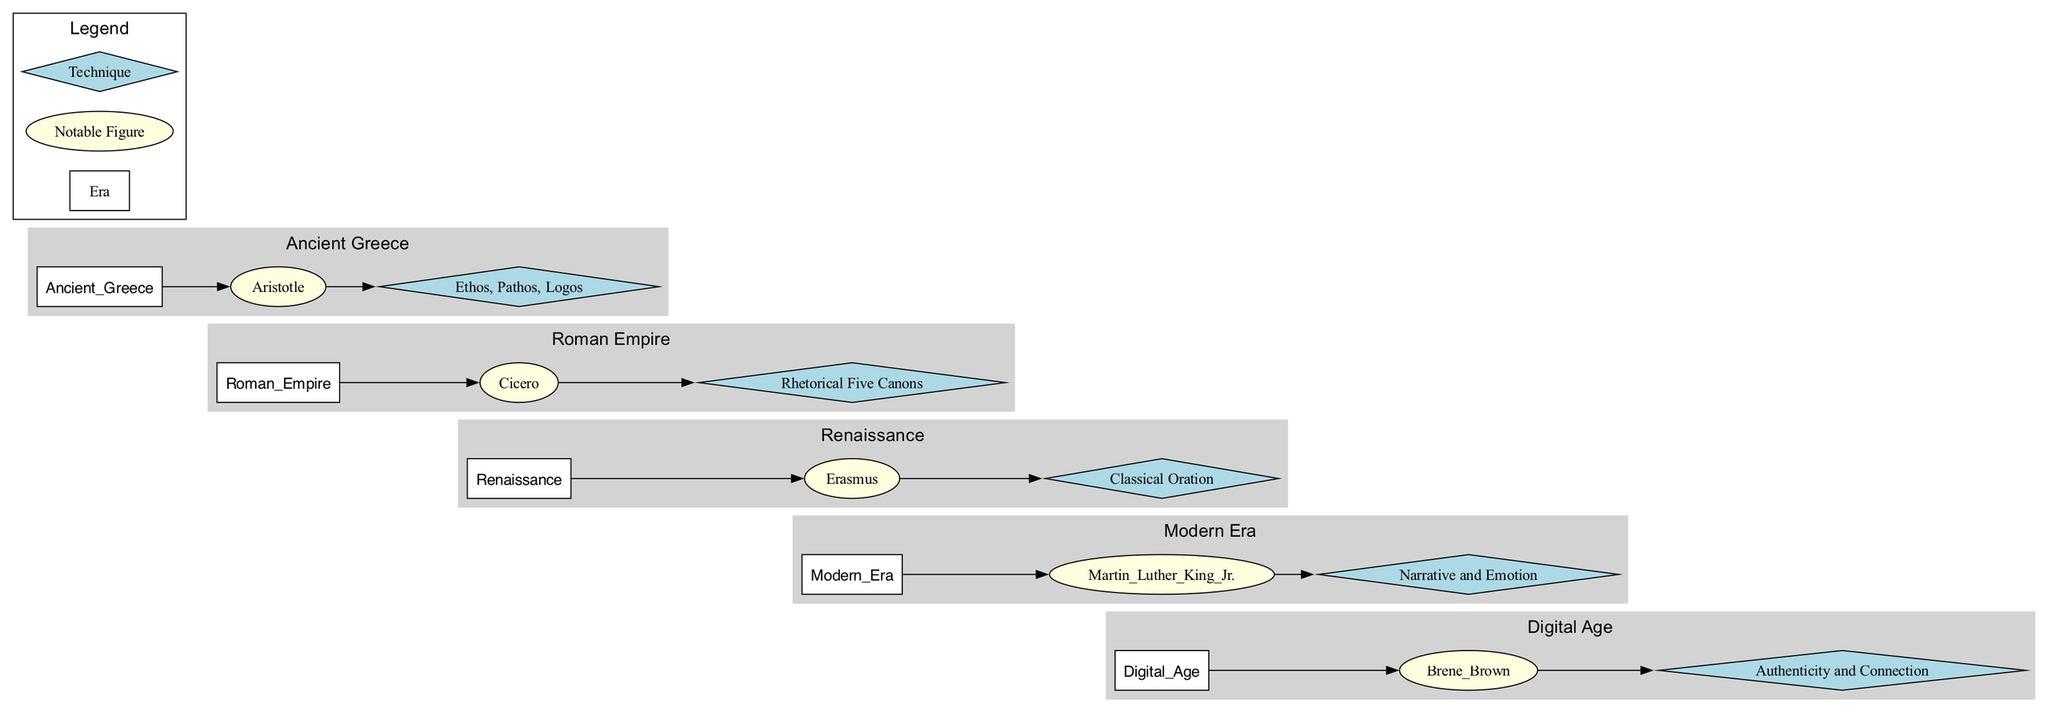What technique is associated with Martin Luther King Jr.? In the diagram, if you look for the node corresponding to Martin Luther King Jr., you'll see it directly connects to the technique node labeled "Narrative and Emotion."
Answer: Narrative and Emotion Which notable figure is linked with the era of the Roman Empire? By finding the Roman Empire era node, you can trace a direct edge to the associated figure labeled "Cicero."
Answer: Cicero How many main eras are depicted in the diagram? Counting the distinct eras mentioned in the diagram, you can find five: Ancient Greece, Roman Empire, Renaissance, Modern Era, and Digital Age.
Answer: 5 What is the color used for the technique nodes? Looking at the style of the diagram, the technique nodes are represented in a light blue color.
Answer: Light blue Who is the notable figure from the Digital Age? The last subgraph, representing the Digital Age, connects directly to the figure labeled "Brene Brown."
Answer: Brene Brown Which technique is emphasized during the Renaissance? Moving to the Renaissance era node, the connecting technique is labeled "Classical Oration."
Answer: Classical Oration What are the first and last notable figures in the timeline of public speaking techniques shown? Starting from the first node in Ancient Greece, the first figure is "Aristotle," and moving to the last node in the Digital Age leads to "Brene Brown."
Answer: Aristotle and Brene Brown How are the eras visually linked in the diagram? The diagram visually connects the eras using invisible edges to illustrate the chronological progression from Ancient Greece to the Digital Age.
Answer: Invisible edges What style represents the era nodes in the diagram? Each era node is formatted as a box shape with a filled attribute for visibility and clarity, which emphasizes the structural layout of the diagram.
Answer: Box shape 